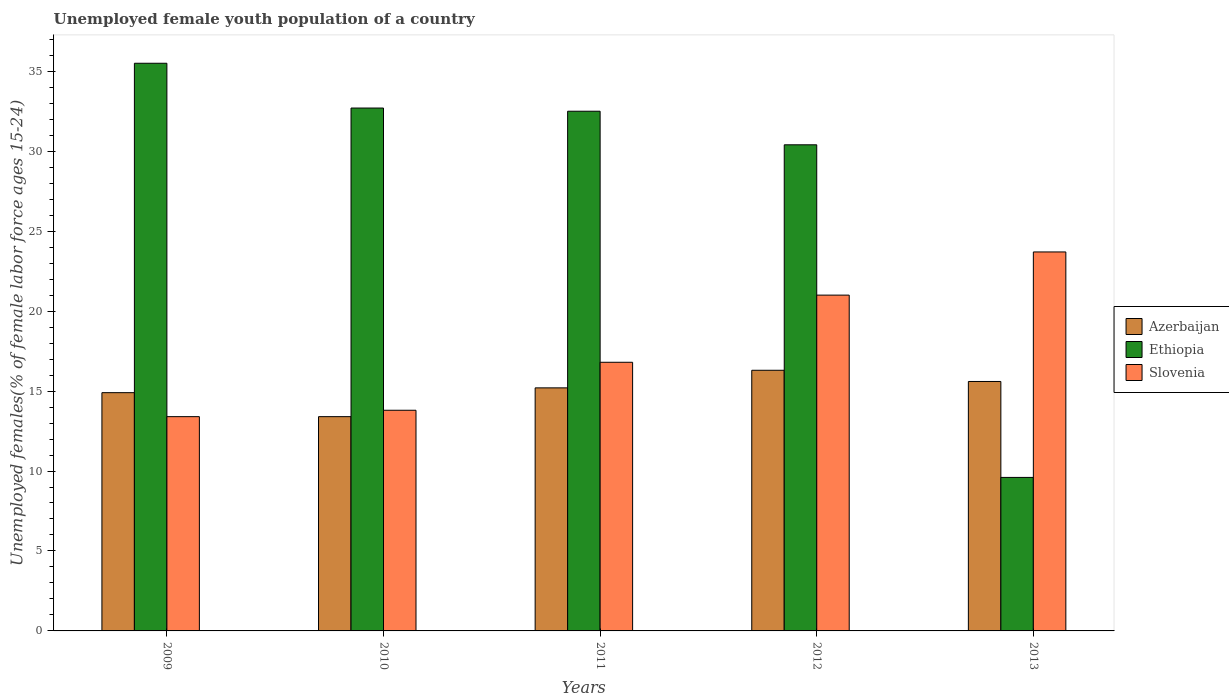Are the number of bars on each tick of the X-axis equal?
Make the answer very short. Yes. What is the percentage of unemployed female youth population in Slovenia in 2010?
Your answer should be compact. 13.8. Across all years, what is the maximum percentage of unemployed female youth population in Azerbaijan?
Your response must be concise. 16.3. Across all years, what is the minimum percentage of unemployed female youth population in Azerbaijan?
Give a very brief answer. 13.4. In which year was the percentage of unemployed female youth population in Slovenia maximum?
Ensure brevity in your answer.  2013. In which year was the percentage of unemployed female youth population in Azerbaijan minimum?
Your answer should be compact. 2010. What is the total percentage of unemployed female youth population in Slovenia in the graph?
Your response must be concise. 88.7. What is the difference between the percentage of unemployed female youth population in Ethiopia in 2012 and that in 2013?
Provide a short and direct response. 20.8. What is the difference between the percentage of unemployed female youth population in Azerbaijan in 2012 and the percentage of unemployed female youth population in Slovenia in 2013?
Your response must be concise. -7.4. What is the average percentage of unemployed female youth population in Azerbaijan per year?
Make the answer very short. 15.08. In the year 2010, what is the difference between the percentage of unemployed female youth population in Ethiopia and percentage of unemployed female youth population in Slovenia?
Keep it short and to the point. 18.9. In how many years, is the percentage of unemployed female youth population in Slovenia greater than 7 %?
Give a very brief answer. 5. What is the ratio of the percentage of unemployed female youth population in Azerbaijan in 2009 to that in 2010?
Offer a terse response. 1.11. Is the percentage of unemployed female youth population in Azerbaijan in 2010 less than that in 2012?
Your response must be concise. Yes. What is the difference between the highest and the second highest percentage of unemployed female youth population in Ethiopia?
Offer a very short reply. 2.8. What is the difference between the highest and the lowest percentage of unemployed female youth population in Ethiopia?
Offer a terse response. 25.9. What does the 3rd bar from the left in 2011 represents?
Provide a short and direct response. Slovenia. What does the 2nd bar from the right in 2009 represents?
Provide a succinct answer. Ethiopia. Are all the bars in the graph horizontal?
Ensure brevity in your answer.  No. Are the values on the major ticks of Y-axis written in scientific E-notation?
Your answer should be very brief. No. Does the graph contain any zero values?
Your answer should be very brief. No. Where does the legend appear in the graph?
Give a very brief answer. Center right. What is the title of the graph?
Your answer should be very brief. Unemployed female youth population of a country. Does "St. Martin (French part)" appear as one of the legend labels in the graph?
Ensure brevity in your answer.  No. What is the label or title of the X-axis?
Provide a succinct answer. Years. What is the label or title of the Y-axis?
Provide a succinct answer. Unemployed females(% of female labor force ages 15-24). What is the Unemployed females(% of female labor force ages 15-24) of Azerbaijan in 2009?
Ensure brevity in your answer.  14.9. What is the Unemployed females(% of female labor force ages 15-24) in Ethiopia in 2009?
Keep it short and to the point. 35.5. What is the Unemployed females(% of female labor force ages 15-24) of Slovenia in 2009?
Provide a short and direct response. 13.4. What is the Unemployed females(% of female labor force ages 15-24) of Azerbaijan in 2010?
Give a very brief answer. 13.4. What is the Unemployed females(% of female labor force ages 15-24) in Ethiopia in 2010?
Provide a succinct answer. 32.7. What is the Unemployed females(% of female labor force ages 15-24) in Slovenia in 2010?
Provide a succinct answer. 13.8. What is the Unemployed females(% of female labor force ages 15-24) of Azerbaijan in 2011?
Provide a short and direct response. 15.2. What is the Unemployed females(% of female labor force ages 15-24) of Ethiopia in 2011?
Give a very brief answer. 32.5. What is the Unemployed females(% of female labor force ages 15-24) in Slovenia in 2011?
Your answer should be very brief. 16.8. What is the Unemployed females(% of female labor force ages 15-24) in Azerbaijan in 2012?
Ensure brevity in your answer.  16.3. What is the Unemployed females(% of female labor force ages 15-24) of Ethiopia in 2012?
Your response must be concise. 30.4. What is the Unemployed females(% of female labor force ages 15-24) of Azerbaijan in 2013?
Offer a terse response. 15.6. What is the Unemployed females(% of female labor force ages 15-24) in Ethiopia in 2013?
Keep it short and to the point. 9.6. What is the Unemployed females(% of female labor force ages 15-24) in Slovenia in 2013?
Your answer should be compact. 23.7. Across all years, what is the maximum Unemployed females(% of female labor force ages 15-24) in Azerbaijan?
Ensure brevity in your answer.  16.3. Across all years, what is the maximum Unemployed females(% of female labor force ages 15-24) of Ethiopia?
Offer a very short reply. 35.5. Across all years, what is the maximum Unemployed females(% of female labor force ages 15-24) in Slovenia?
Your answer should be compact. 23.7. Across all years, what is the minimum Unemployed females(% of female labor force ages 15-24) in Azerbaijan?
Give a very brief answer. 13.4. Across all years, what is the minimum Unemployed females(% of female labor force ages 15-24) in Ethiopia?
Offer a terse response. 9.6. Across all years, what is the minimum Unemployed females(% of female labor force ages 15-24) in Slovenia?
Ensure brevity in your answer.  13.4. What is the total Unemployed females(% of female labor force ages 15-24) of Azerbaijan in the graph?
Offer a terse response. 75.4. What is the total Unemployed females(% of female labor force ages 15-24) of Ethiopia in the graph?
Offer a terse response. 140.7. What is the total Unemployed females(% of female labor force ages 15-24) in Slovenia in the graph?
Offer a very short reply. 88.7. What is the difference between the Unemployed females(% of female labor force ages 15-24) in Azerbaijan in 2009 and that in 2010?
Your response must be concise. 1.5. What is the difference between the Unemployed females(% of female labor force ages 15-24) of Ethiopia in 2009 and that in 2010?
Provide a succinct answer. 2.8. What is the difference between the Unemployed females(% of female labor force ages 15-24) of Azerbaijan in 2009 and that in 2011?
Provide a succinct answer. -0.3. What is the difference between the Unemployed females(% of female labor force ages 15-24) in Ethiopia in 2009 and that in 2011?
Make the answer very short. 3. What is the difference between the Unemployed females(% of female labor force ages 15-24) in Azerbaijan in 2009 and that in 2012?
Your answer should be compact. -1.4. What is the difference between the Unemployed females(% of female labor force ages 15-24) of Slovenia in 2009 and that in 2012?
Your answer should be compact. -7.6. What is the difference between the Unemployed females(% of female labor force ages 15-24) in Azerbaijan in 2009 and that in 2013?
Your response must be concise. -0.7. What is the difference between the Unemployed females(% of female labor force ages 15-24) in Ethiopia in 2009 and that in 2013?
Make the answer very short. 25.9. What is the difference between the Unemployed females(% of female labor force ages 15-24) in Slovenia in 2009 and that in 2013?
Offer a very short reply. -10.3. What is the difference between the Unemployed females(% of female labor force ages 15-24) in Azerbaijan in 2010 and that in 2011?
Give a very brief answer. -1.8. What is the difference between the Unemployed females(% of female labor force ages 15-24) of Ethiopia in 2010 and that in 2011?
Offer a very short reply. 0.2. What is the difference between the Unemployed females(% of female labor force ages 15-24) in Azerbaijan in 2010 and that in 2012?
Ensure brevity in your answer.  -2.9. What is the difference between the Unemployed females(% of female labor force ages 15-24) of Azerbaijan in 2010 and that in 2013?
Give a very brief answer. -2.2. What is the difference between the Unemployed females(% of female labor force ages 15-24) in Ethiopia in 2010 and that in 2013?
Give a very brief answer. 23.1. What is the difference between the Unemployed females(% of female labor force ages 15-24) of Slovenia in 2010 and that in 2013?
Ensure brevity in your answer.  -9.9. What is the difference between the Unemployed females(% of female labor force ages 15-24) in Slovenia in 2011 and that in 2012?
Ensure brevity in your answer.  -4.2. What is the difference between the Unemployed females(% of female labor force ages 15-24) in Azerbaijan in 2011 and that in 2013?
Give a very brief answer. -0.4. What is the difference between the Unemployed females(% of female labor force ages 15-24) of Ethiopia in 2011 and that in 2013?
Your answer should be compact. 22.9. What is the difference between the Unemployed females(% of female labor force ages 15-24) of Slovenia in 2011 and that in 2013?
Provide a short and direct response. -6.9. What is the difference between the Unemployed females(% of female labor force ages 15-24) in Azerbaijan in 2012 and that in 2013?
Keep it short and to the point. 0.7. What is the difference between the Unemployed females(% of female labor force ages 15-24) of Ethiopia in 2012 and that in 2013?
Make the answer very short. 20.8. What is the difference between the Unemployed females(% of female labor force ages 15-24) of Azerbaijan in 2009 and the Unemployed females(% of female labor force ages 15-24) of Ethiopia in 2010?
Make the answer very short. -17.8. What is the difference between the Unemployed females(% of female labor force ages 15-24) of Ethiopia in 2009 and the Unemployed females(% of female labor force ages 15-24) of Slovenia in 2010?
Make the answer very short. 21.7. What is the difference between the Unemployed females(% of female labor force ages 15-24) of Azerbaijan in 2009 and the Unemployed females(% of female labor force ages 15-24) of Ethiopia in 2011?
Offer a terse response. -17.6. What is the difference between the Unemployed females(% of female labor force ages 15-24) in Ethiopia in 2009 and the Unemployed females(% of female labor force ages 15-24) in Slovenia in 2011?
Ensure brevity in your answer.  18.7. What is the difference between the Unemployed females(% of female labor force ages 15-24) in Azerbaijan in 2009 and the Unemployed females(% of female labor force ages 15-24) in Ethiopia in 2012?
Provide a short and direct response. -15.5. What is the difference between the Unemployed females(% of female labor force ages 15-24) in Ethiopia in 2009 and the Unemployed females(% of female labor force ages 15-24) in Slovenia in 2012?
Provide a succinct answer. 14.5. What is the difference between the Unemployed females(% of female labor force ages 15-24) of Azerbaijan in 2009 and the Unemployed females(% of female labor force ages 15-24) of Ethiopia in 2013?
Ensure brevity in your answer.  5.3. What is the difference between the Unemployed females(% of female labor force ages 15-24) in Azerbaijan in 2009 and the Unemployed females(% of female labor force ages 15-24) in Slovenia in 2013?
Give a very brief answer. -8.8. What is the difference between the Unemployed females(% of female labor force ages 15-24) in Ethiopia in 2009 and the Unemployed females(% of female labor force ages 15-24) in Slovenia in 2013?
Your response must be concise. 11.8. What is the difference between the Unemployed females(% of female labor force ages 15-24) of Azerbaijan in 2010 and the Unemployed females(% of female labor force ages 15-24) of Ethiopia in 2011?
Make the answer very short. -19.1. What is the difference between the Unemployed females(% of female labor force ages 15-24) in Ethiopia in 2010 and the Unemployed females(% of female labor force ages 15-24) in Slovenia in 2011?
Offer a terse response. 15.9. What is the difference between the Unemployed females(% of female labor force ages 15-24) in Azerbaijan in 2010 and the Unemployed females(% of female labor force ages 15-24) in Ethiopia in 2012?
Your answer should be compact. -17. What is the difference between the Unemployed females(% of female labor force ages 15-24) of Azerbaijan in 2011 and the Unemployed females(% of female labor force ages 15-24) of Ethiopia in 2012?
Offer a very short reply. -15.2. What is the difference between the Unemployed females(% of female labor force ages 15-24) in Azerbaijan in 2011 and the Unemployed females(% of female labor force ages 15-24) in Slovenia in 2012?
Offer a very short reply. -5.8. What is the difference between the Unemployed females(% of female labor force ages 15-24) of Ethiopia in 2011 and the Unemployed females(% of female labor force ages 15-24) of Slovenia in 2012?
Provide a succinct answer. 11.5. What is the difference between the Unemployed females(% of female labor force ages 15-24) in Azerbaijan in 2011 and the Unemployed females(% of female labor force ages 15-24) in Ethiopia in 2013?
Offer a very short reply. 5.6. What is the difference between the Unemployed females(% of female labor force ages 15-24) of Azerbaijan in 2012 and the Unemployed females(% of female labor force ages 15-24) of Ethiopia in 2013?
Offer a very short reply. 6.7. What is the difference between the Unemployed females(% of female labor force ages 15-24) in Ethiopia in 2012 and the Unemployed females(% of female labor force ages 15-24) in Slovenia in 2013?
Keep it short and to the point. 6.7. What is the average Unemployed females(% of female labor force ages 15-24) in Azerbaijan per year?
Provide a succinct answer. 15.08. What is the average Unemployed females(% of female labor force ages 15-24) of Ethiopia per year?
Offer a very short reply. 28.14. What is the average Unemployed females(% of female labor force ages 15-24) of Slovenia per year?
Your answer should be very brief. 17.74. In the year 2009, what is the difference between the Unemployed females(% of female labor force ages 15-24) of Azerbaijan and Unemployed females(% of female labor force ages 15-24) of Ethiopia?
Offer a very short reply. -20.6. In the year 2009, what is the difference between the Unemployed females(% of female labor force ages 15-24) in Azerbaijan and Unemployed females(% of female labor force ages 15-24) in Slovenia?
Ensure brevity in your answer.  1.5. In the year 2009, what is the difference between the Unemployed females(% of female labor force ages 15-24) in Ethiopia and Unemployed females(% of female labor force ages 15-24) in Slovenia?
Give a very brief answer. 22.1. In the year 2010, what is the difference between the Unemployed females(% of female labor force ages 15-24) of Azerbaijan and Unemployed females(% of female labor force ages 15-24) of Ethiopia?
Your answer should be compact. -19.3. In the year 2010, what is the difference between the Unemployed females(% of female labor force ages 15-24) of Azerbaijan and Unemployed females(% of female labor force ages 15-24) of Slovenia?
Give a very brief answer. -0.4. In the year 2010, what is the difference between the Unemployed females(% of female labor force ages 15-24) of Ethiopia and Unemployed females(% of female labor force ages 15-24) of Slovenia?
Provide a short and direct response. 18.9. In the year 2011, what is the difference between the Unemployed females(% of female labor force ages 15-24) in Azerbaijan and Unemployed females(% of female labor force ages 15-24) in Ethiopia?
Offer a terse response. -17.3. In the year 2012, what is the difference between the Unemployed females(% of female labor force ages 15-24) in Azerbaijan and Unemployed females(% of female labor force ages 15-24) in Ethiopia?
Provide a succinct answer. -14.1. In the year 2012, what is the difference between the Unemployed females(% of female labor force ages 15-24) in Ethiopia and Unemployed females(% of female labor force ages 15-24) in Slovenia?
Your response must be concise. 9.4. In the year 2013, what is the difference between the Unemployed females(% of female labor force ages 15-24) of Azerbaijan and Unemployed females(% of female labor force ages 15-24) of Ethiopia?
Give a very brief answer. 6. In the year 2013, what is the difference between the Unemployed females(% of female labor force ages 15-24) of Ethiopia and Unemployed females(% of female labor force ages 15-24) of Slovenia?
Offer a very short reply. -14.1. What is the ratio of the Unemployed females(% of female labor force ages 15-24) in Azerbaijan in 2009 to that in 2010?
Your answer should be very brief. 1.11. What is the ratio of the Unemployed females(% of female labor force ages 15-24) in Ethiopia in 2009 to that in 2010?
Your answer should be compact. 1.09. What is the ratio of the Unemployed females(% of female labor force ages 15-24) in Azerbaijan in 2009 to that in 2011?
Offer a very short reply. 0.98. What is the ratio of the Unemployed females(% of female labor force ages 15-24) in Ethiopia in 2009 to that in 2011?
Provide a short and direct response. 1.09. What is the ratio of the Unemployed females(% of female labor force ages 15-24) of Slovenia in 2009 to that in 2011?
Your answer should be compact. 0.8. What is the ratio of the Unemployed females(% of female labor force ages 15-24) of Azerbaijan in 2009 to that in 2012?
Provide a short and direct response. 0.91. What is the ratio of the Unemployed females(% of female labor force ages 15-24) of Ethiopia in 2009 to that in 2012?
Offer a very short reply. 1.17. What is the ratio of the Unemployed females(% of female labor force ages 15-24) in Slovenia in 2009 to that in 2012?
Ensure brevity in your answer.  0.64. What is the ratio of the Unemployed females(% of female labor force ages 15-24) in Azerbaijan in 2009 to that in 2013?
Offer a very short reply. 0.96. What is the ratio of the Unemployed females(% of female labor force ages 15-24) in Ethiopia in 2009 to that in 2013?
Your answer should be very brief. 3.7. What is the ratio of the Unemployed females(% of female labor force ages 15-24) of Slovenia in 2009 to that in 2013?
Provide a short and direct response. 0.57. What is the ratio of the Unemployed females(% of female labor force ages 15-24) of Azerbaijan in 2010 to that in 2011?
Keep it short and to the point. 0.88. What is the ratio of the Unemployed females(% of female labor force ages 15-24) of Slovenia in 2010 to that in 2011?
Offer a terse response. 0.82. What is the ratio of the Unemployed females(% of female labor force ages 15-24) in Azerbaijan in 2010 to that in 2012?
Your answer should be very brief. 0.82. What is the ratio of the Unemployed females(% of female labor force ages 15-24) in Ethiopia in 2010 to that in 2012?
Keep it short and to the point. 1.08. What is the ratio of the Unemployed females(% of female labor force ages 15-24) of Slovenia in 2010 to that in 2012?
Offer a very short reply. 0.66. What is the ratio of the Unemployed females(% of female labor force ages 15-24) of Azerbaijan in 2010 to that in 2013?
Provide a succinct answer. 0.86. What is the ratio of the Unemployed females(% of female labor force ages 15-24) in Ethiopia in 2010 to that in 2013?
Your answer should be very brief. 3.41. What is the ratio of the Unemployed females(% of female labor force ages 15-24) of Slovenia in 2010 to that in 2013?
Provide a succinct answer. 0.58. What is the ratio of the Unemployed females(% of female labor force ages 15-24) of Azerbaijan in 2011 to that in 2012?
Offer a very short reply. 0.93. What is the ratio of the Unemployed females(% of female labor force ages 15-24) in Ethiopia in 2011 to that in 2012?
Your answer should be very brief. 1.07. What is the ratio of the Unemployed females(% of female labor force ages 15-24) in Azerbaijan in 2011 to that in 2013?
Your answer should be compact. 0.97. What is the ratio of the Unemployed females(% of female labor force ages 15-24) in Ethiopia in 2011 to that in 2013?
Your response must be concise. 3.39. What is the ratio of the Unemployed females(% of female labor force ages 15-24) in Slovenia in 2011 to that in 2013?
Keep it short and to the point. 0.71. What is the ratio of the Unemployed females(% of female labor force ages 15-24) in Azerbaijan in 2012 to that in 2013?
Offer a terse response. 1.04. What is the ratio of the Unemployed females(% of female labor force ages 15-24) in Ethiopia in 2012 to that in 2013?
Offer a terse response. 3.17. What is the ratio of the Unemployed females(% of female labor force ages 15-24) in Slovenia in 2012 to that in 2013?
Provide a succinct answer. 0.89. What is the difference between the highest and the second highest Unemployed females(% of female labor force ages 15-24) of Ethiopia?
Keep it short and to the point. 2.8. What is the difference between the highest and the lowest Unemployed females(% of female labor force ages 15-24) of Azerbaijan?
Provide a succinct answer. 2.9. What is the difference between the highest and the lowest Unemployed females(% of female labor force ages 15-24) of Ethiopia?
Offer a terse response. 25.9. What is the difference between the highest and the lowest Unemployed females(% of female labor force ages 15-24) in Slovenia?
Your answer should be compact. 10.3. 